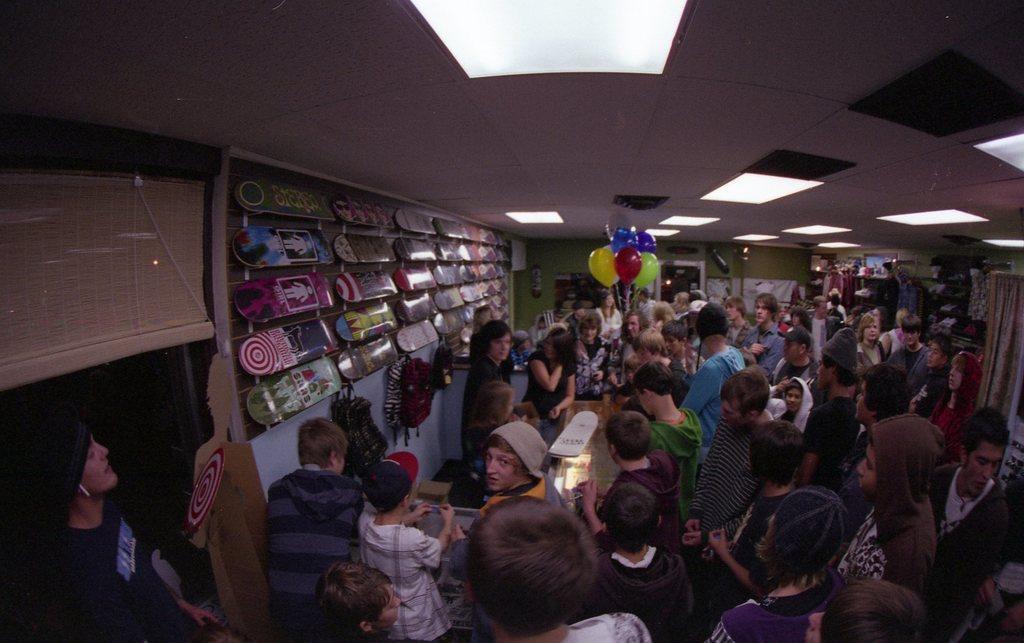Describe this image in one or two sentences. In this image we can see people standing on the floor, skate boards attached to the wall, blinds, electric lights to the roof, bunch of balloons, display screens, fire extinguisher and bags attached to the wall. 